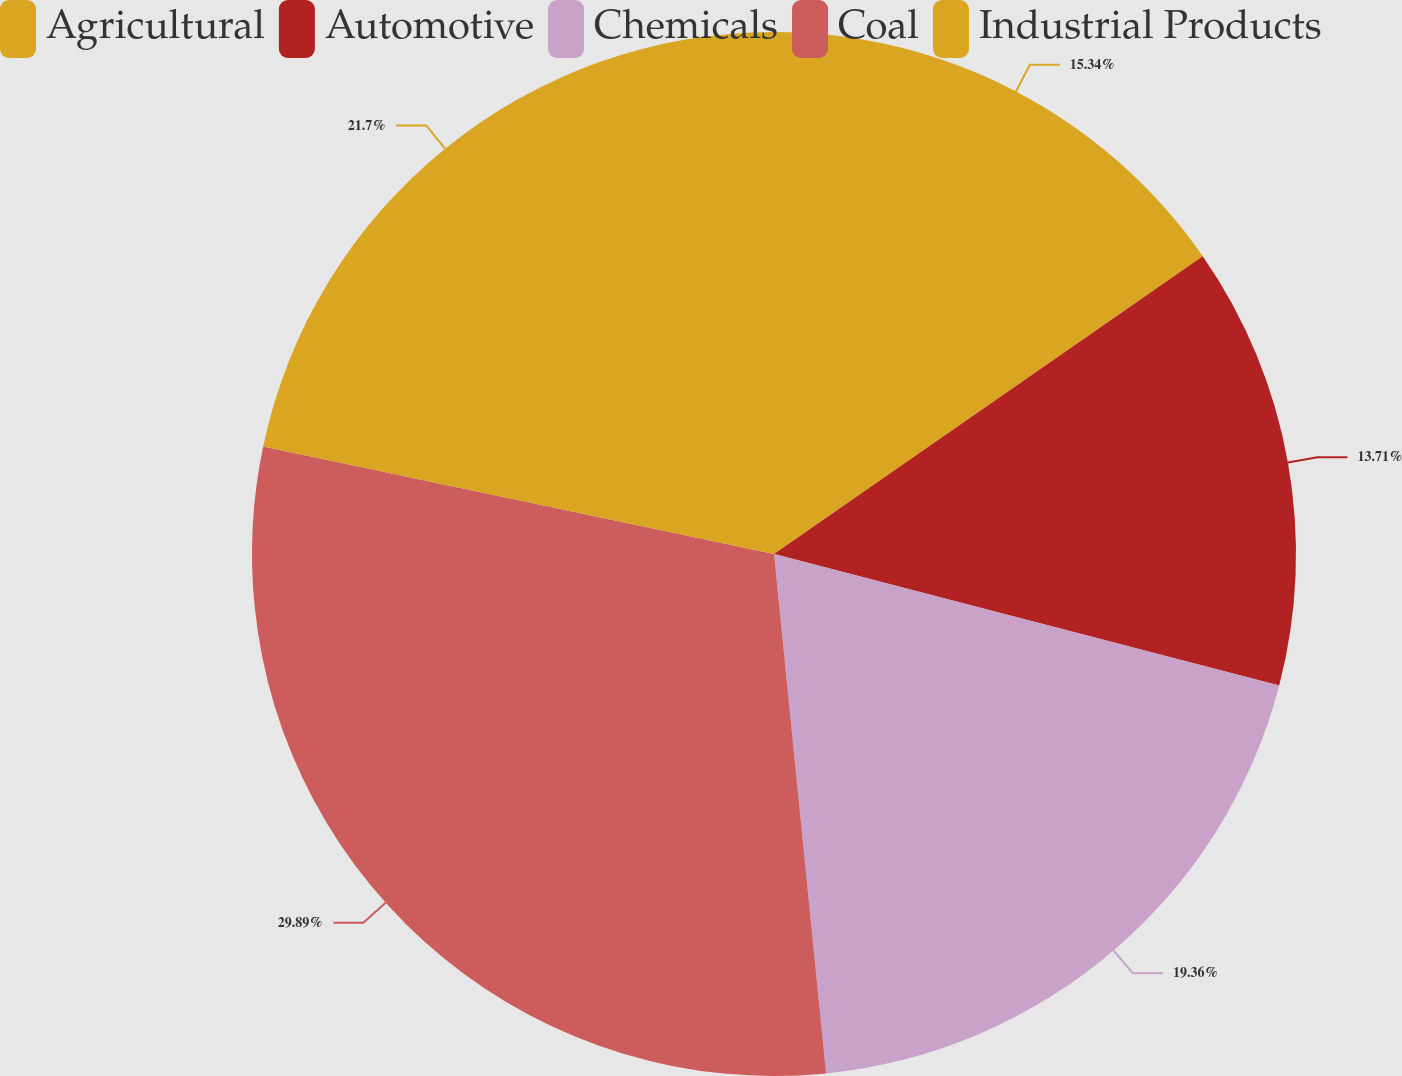Convert chart to OTSL. <chart><loc_0><loc_0><loc_500><loc_500><pie_chart><fcel>Agricultural<fcel>Automotive<fcel>Chemicals<fcel>Coal<fcel>Industrial Products<nl><fcel>15.34%<fcel>13.71%<fcel>19.36%<fcel>29.89%<fcel>21.7%<nl></chart> 